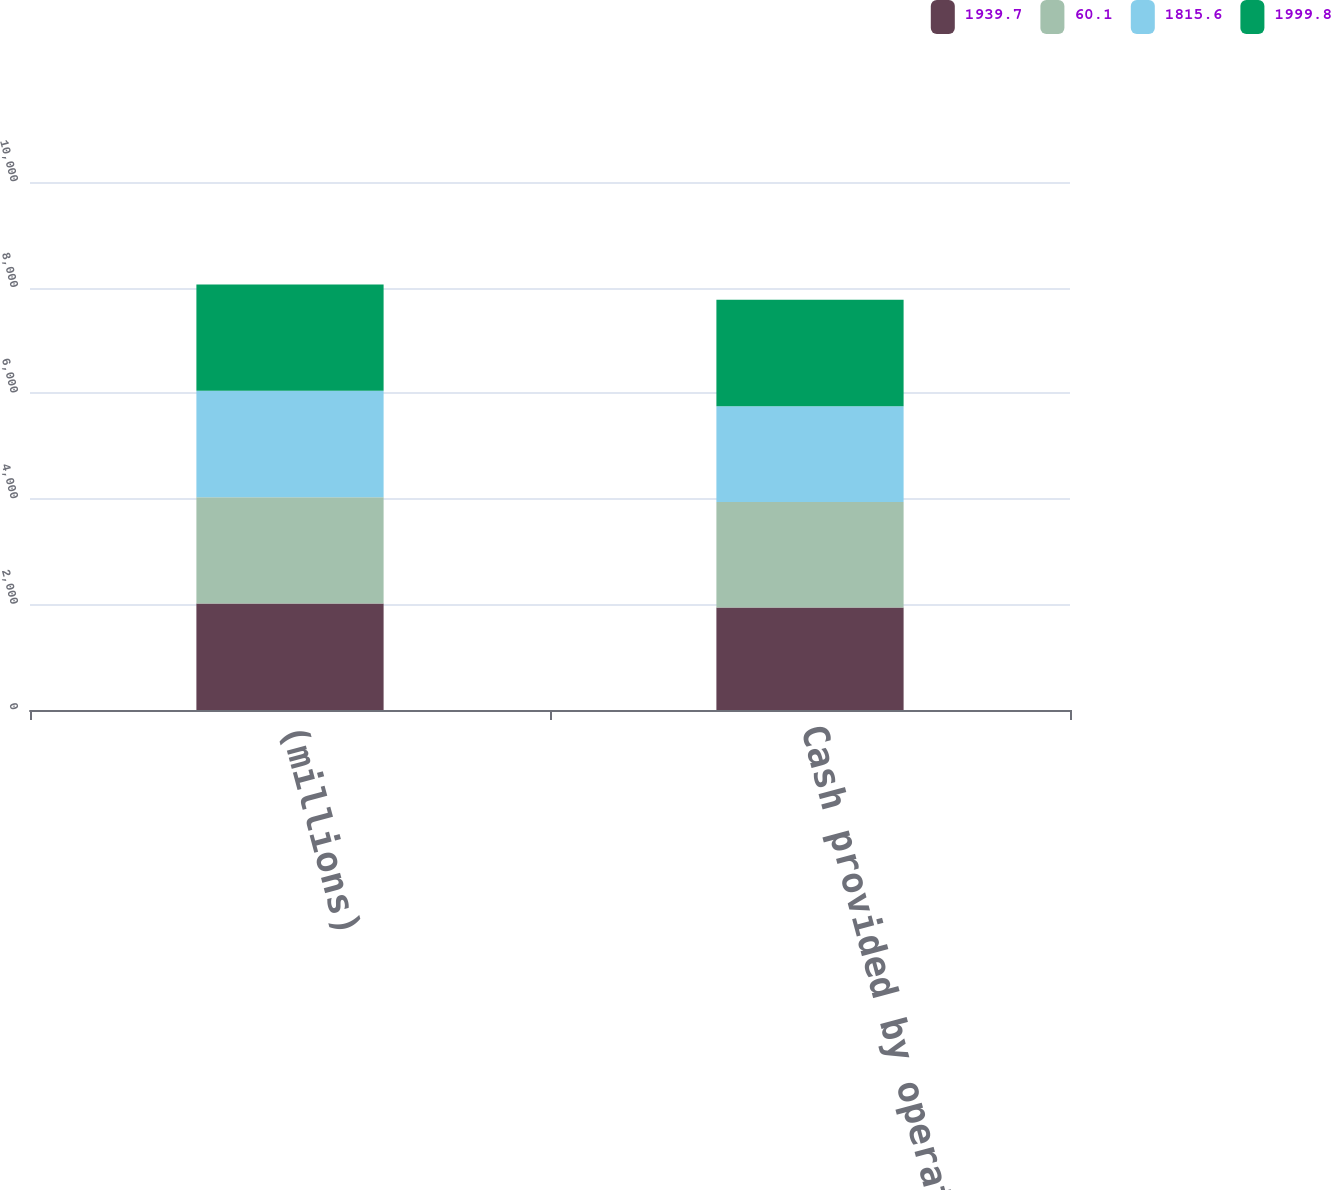Convert chart. <chart><loc_0><loc_0><loc_500><loc_500><stacked_bar_chart><ecel><fcel>(millions)<fcel>Cash provided by operating<nl><fcel>1939.7<fcel>2016<fcel>1939.7<nl><fcel>60.1<fcel>2015<fcel>1999.8<nl><fcel>1815.6<fcel>2014<fcel>1815.6<nl><fcel>1999.8<fcel>2016<fcel>2014<nl></chart> 